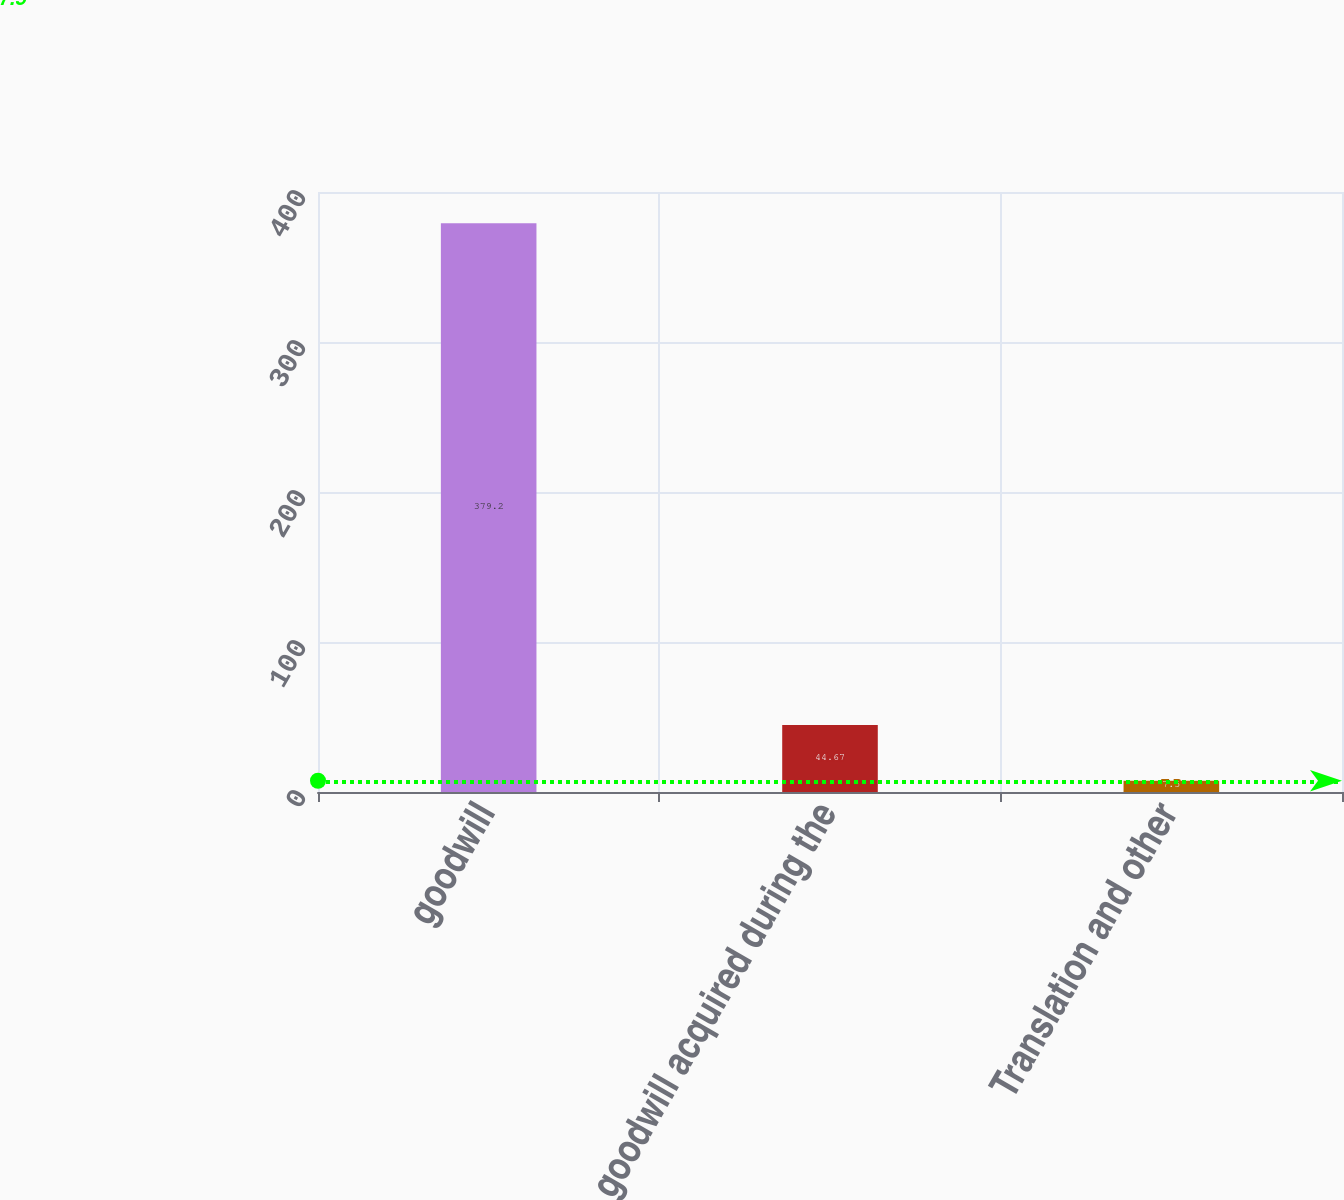Convert chart. <chart><loc_0><loc_0><loc_500><loc_500><bar_chart><fcel>goodwill<fcel>goodwill acquired during the<fcel>Translation and other<nl><fcel>379.2<fcel>44.67<fcel>7.5<nl></chart> 